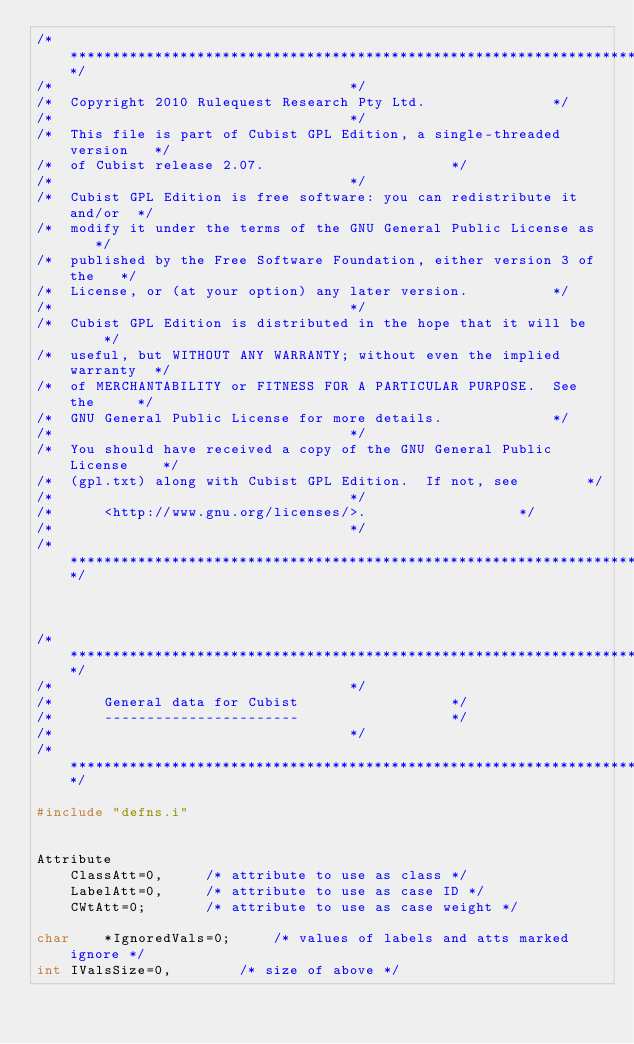<code> <loc_0><loc_0><loc_500><loc_500><_C_>/*************************************************************************/
/*									 */
/*  Copyright 2010 Rulequest Research Pty Ltd.				 */
/*									 */
/*  This file is part of Cubist GPL Edition, a single-threaded version	 */
/*  of Cubist release 2.07.						 */
/*									 */
/*  Cubist GPL Edition is free software: you can redistribute it and/or	 */
/*  modify it under the terms of the GNU General Public License as	 */
/*  published by the Free Software Foundation, either version 3 of the	 */
/*  License, or (at your option) any later version.			 */
/*									 */
/*  Cubist GPL Edition is distributed in the hope that it will be	 */
/*  useful, but WITHOUT ANY WARRANTY; without even the implied warranty	 */
/*  of MERCHANTABILITY or FITNESS FOR A PARTICULAR PURPOSE.  See the	 */
/*  GNU General Public License for more details.			 */
/*									 */
/*  You should have received a copy of the GNU General Public License	 */
/*  (gpl.txt) along with Cubist GPL Edition.  If not, see		 */
/*									 */
/*      <http://www.gnu.org/licenses/>.					 */
/*									 */
/*************************************************************************/



/*************************************************************************/
/*									 */
/*		General data for Cubist					 */
/*		-----------------------					 */
/*									 */
/*************************************************************************/

#include "defns.i"


Attribute
	ClassAtt=0,		/* attribute to use as class */
	LabelAtt=0,		/* attribute to use as case ID */
	CWtAtt=0;		/* attribute to use as case weight */

char	*IgnoredVals=0;		/* values of labels and atts marked ignore */
int	IValsSize=0,		/* size of above */</code> 